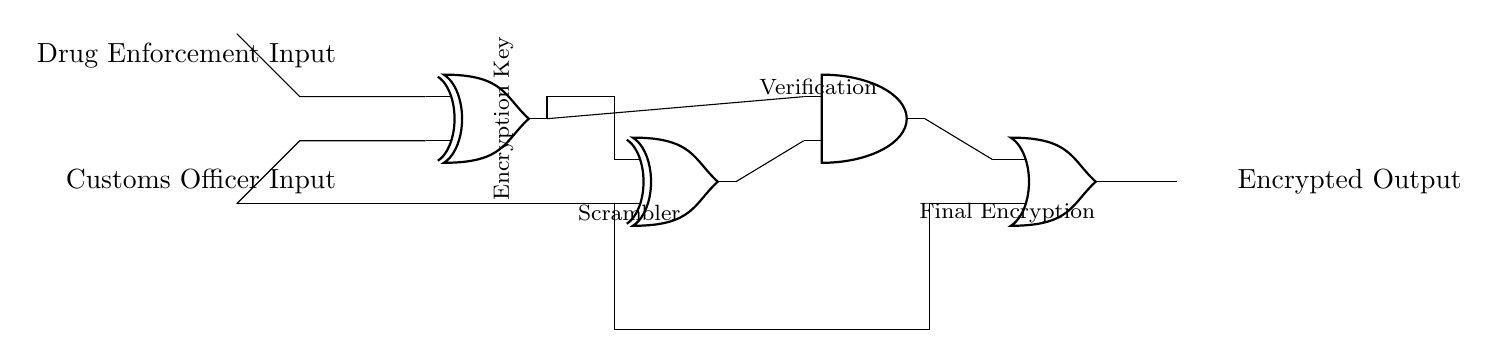What components are used in this circuit? The circuit includes two XOR gates, one AND gate, and one OR gate, which are standard logic gates used for processing inputs and generating outputs.
Answer: Two XOR gates, one AND gate, one OR gate What is the purpose of the XOR gates in this circuit? The XOR gates serve to scramble the inputs from the drug enforcement and customs officer, creating an encrypted element by leveraging the properties of XOR operations, where the output will only be true if the inputs differ.
Answer: Scrambling inputs How many input signals are there in the circuit? The circuit has two input signals, one for the drug enforcement agent and another for the customs officer, which are each represented on the left side of the diagram.
Answer: Two input signals What logical operation does the AND gate perform on the outputs? The AND gate performs a logical multiplication, meaning it will only output a "true" or one when both inputs to the gate are true; thereby combining the results from the two XOR gates.
Answer: Logical multiplication Which gate is used to finalize the encryption process? The OR gate is used to finalize the encryption process by combining outputs from both the AND gate and one of the XOR gates, ensuring that at least one input produces a "true" output for the final encrypted output.
Answer: OR gate What is the relationship between the inputs to the XOR gates? The inputs to the XOR gates are connected in such a way that the output of XOR1 feeds into one of the inputs of the AND gate, and the output from XOR2 can also contribute to the AND gate input, making their outputs dependent.
Answer: Dependent relationship What does the notation "Encryption Key" indicate in this circuit? The notation points to a specific signal or set of signals that serve as a mechanism for encryption, showing its importance in the communication process by influencing the behavior of the XOR gates.
Answer: Encryption mechanism 